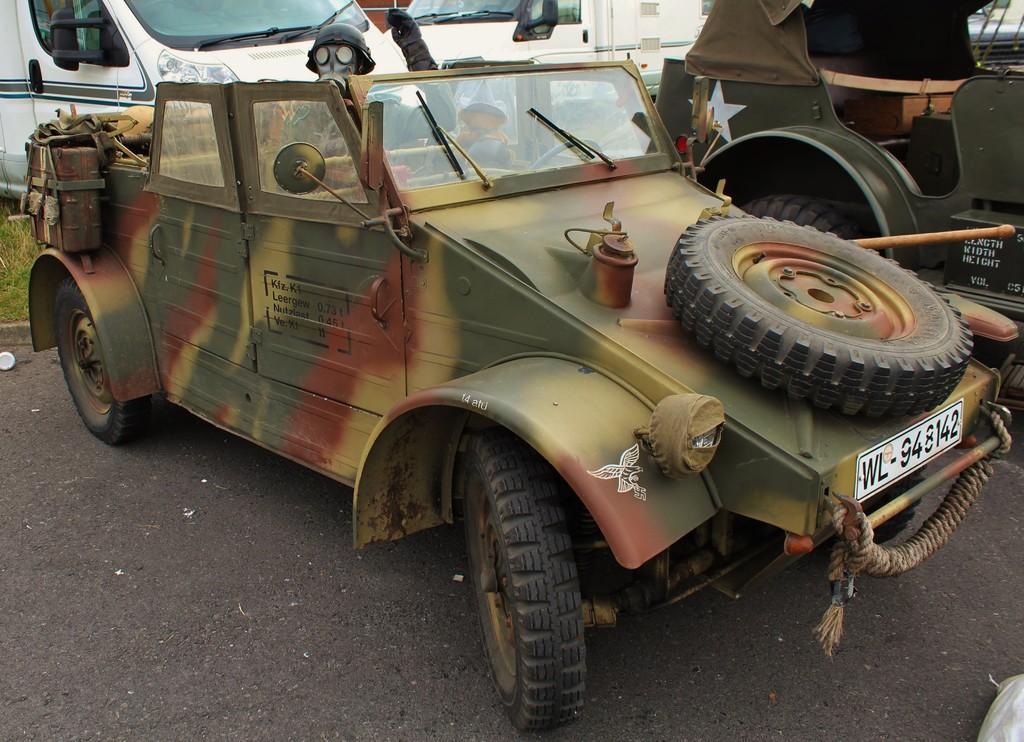Please provide a concise description of this image. There are vehicles parked on the road. In the background, there are white color vehicles and there's grass on the ground. 